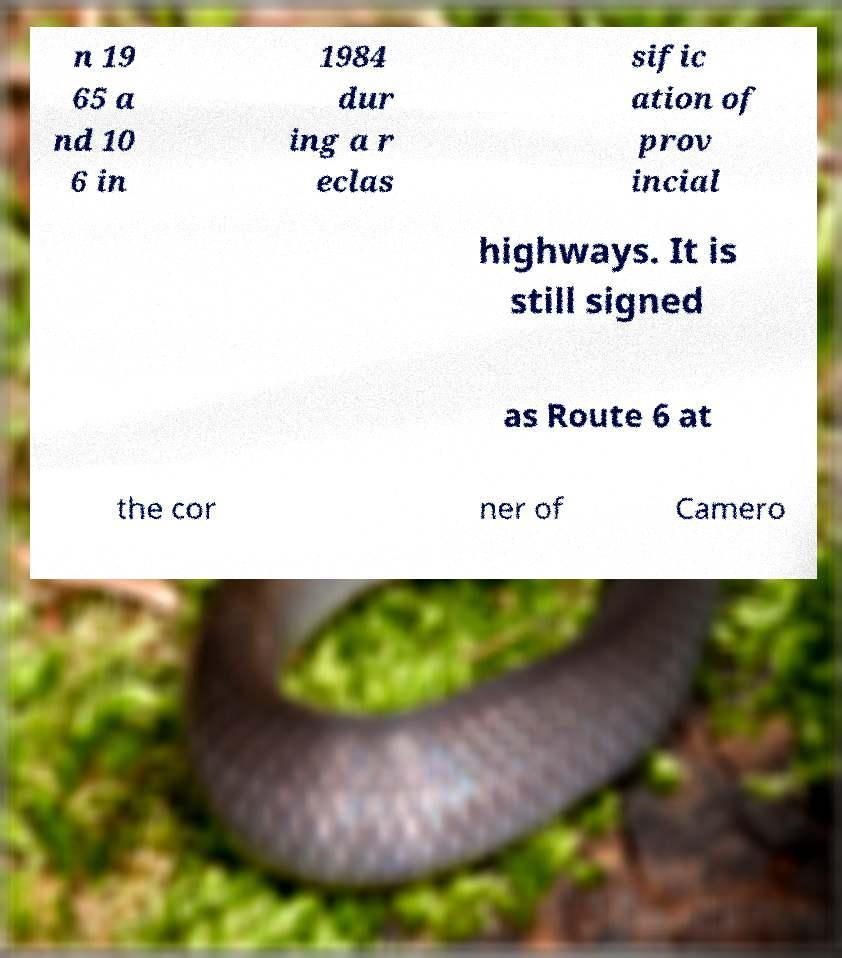What messages or text are displayed in this image? I need them in a readable, typed format. n 19 65 a nd 10 6 in 1984 dur ing a r eclas sific ation of prov incial highways. It is still signed as Route 6 at the cor ner of Camero 